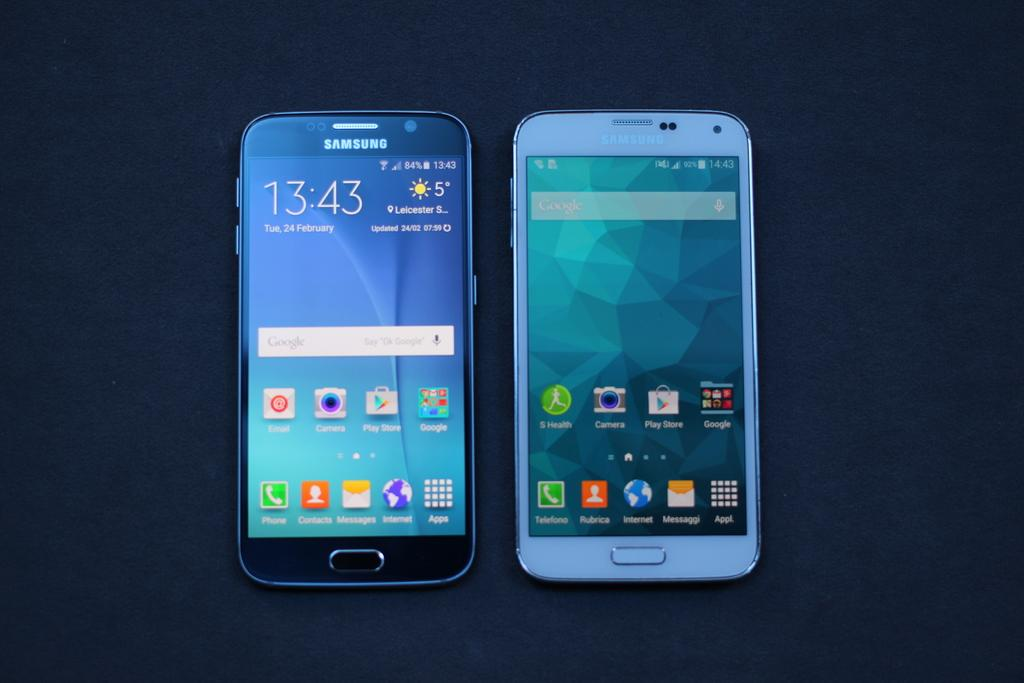<image>
Offer a succinct explanation of the picture presented. Two cellphones side by side including one that has the time at 13:43. 